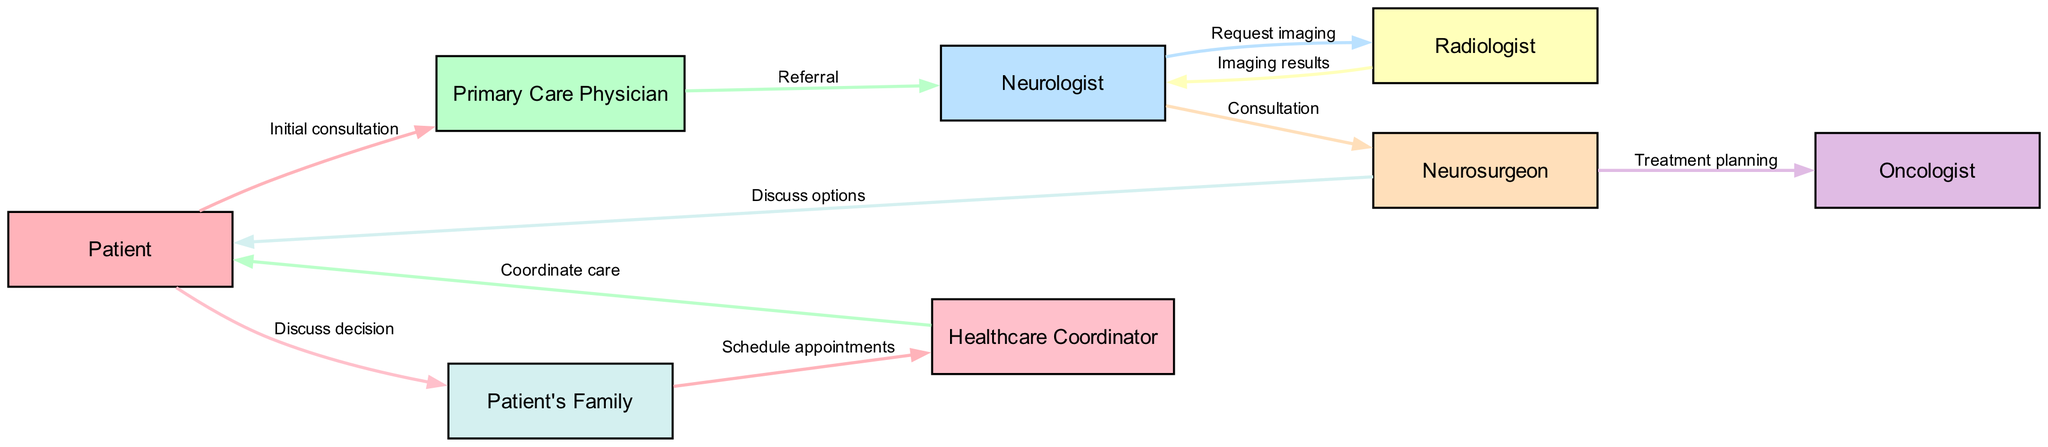What is the first step in the patient referral process? The first step is the "Initial consultation" between the Patient and the Primary Care Physician, as indicated by the first edge in the diagram.
Answer: Initial consultation How many participants are involved in the referral process? There are eight participants represented as nodes in the diagram: Patient, Primary Care Physician, Neurologist, Radiologist, Neurosurgeon, Oncologist, Patient's Family, and Healthcare Coordinator.
Answer: Eight What does the Neurologist request from the Radiologist? The Neurologist requests "imaging" from the Radiologist, which shows the direct connection between them for further examination.
Answer: Imaging What role does the Healthcare Coordinator play in the process? The Healthcare Coordinator's role is to "Coordinate care" among all parties, facilitating communication and appointment scheduling for the Patient.
Answer: Coordinate care Which two specialists are involved after the Neurosurgeon in the diagram? The two specialists involved after the Neurosurgeon are the Oncologist and the Patient, where the Neurosurgeon discusses treatment options with both.
Answer: Oncologist and Patient What is the purpose of the edge labeled "Discuss decision" in the diagram? The purpose of this edge is to illustrate the conversation between the Patient and the Patient's Family regarding treatment options, representing shared decision-making.
Answer: Discuss decision Between which two participants does the edge labeled "Referral" exist? The edge labeled "Referral" exists between the Primary Care Physician and the Neurologist, indicating that the Primary Care Physician refers the Patient to the specialist.
Answer: Primary Care Physician and Neurologist What action is taken by the Patient's Family concerning the Healthcare Coordinator? The Patient's Family takes the action to "Schedule appointments" with the Healthcare Coordinator, as denoted in the flow of the diagram.
Answer: Schedule appointments How does the diagram indicate the sequence of communication? The diagram demonstrates the sequence of communication through directed edges connecting the participants, where each edge has a label that describes the interaction or action occurring between them.
Answer: Directed edges 